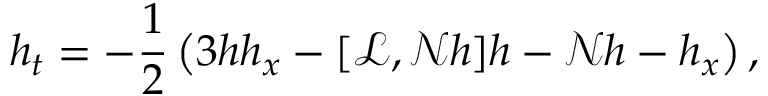Convert formula to latex. <formula><loc_0><loc_0><loc_500><loc_500>h _ { t } = - \frac { 1 } { 2 } \left ( 3 h h _ { x } - [ \ m a t h s c r { L } , \ m a t h s c r { N } h ] h - \ m a t h s c r { N } h - h _ { x } \right ) ,</formula> 